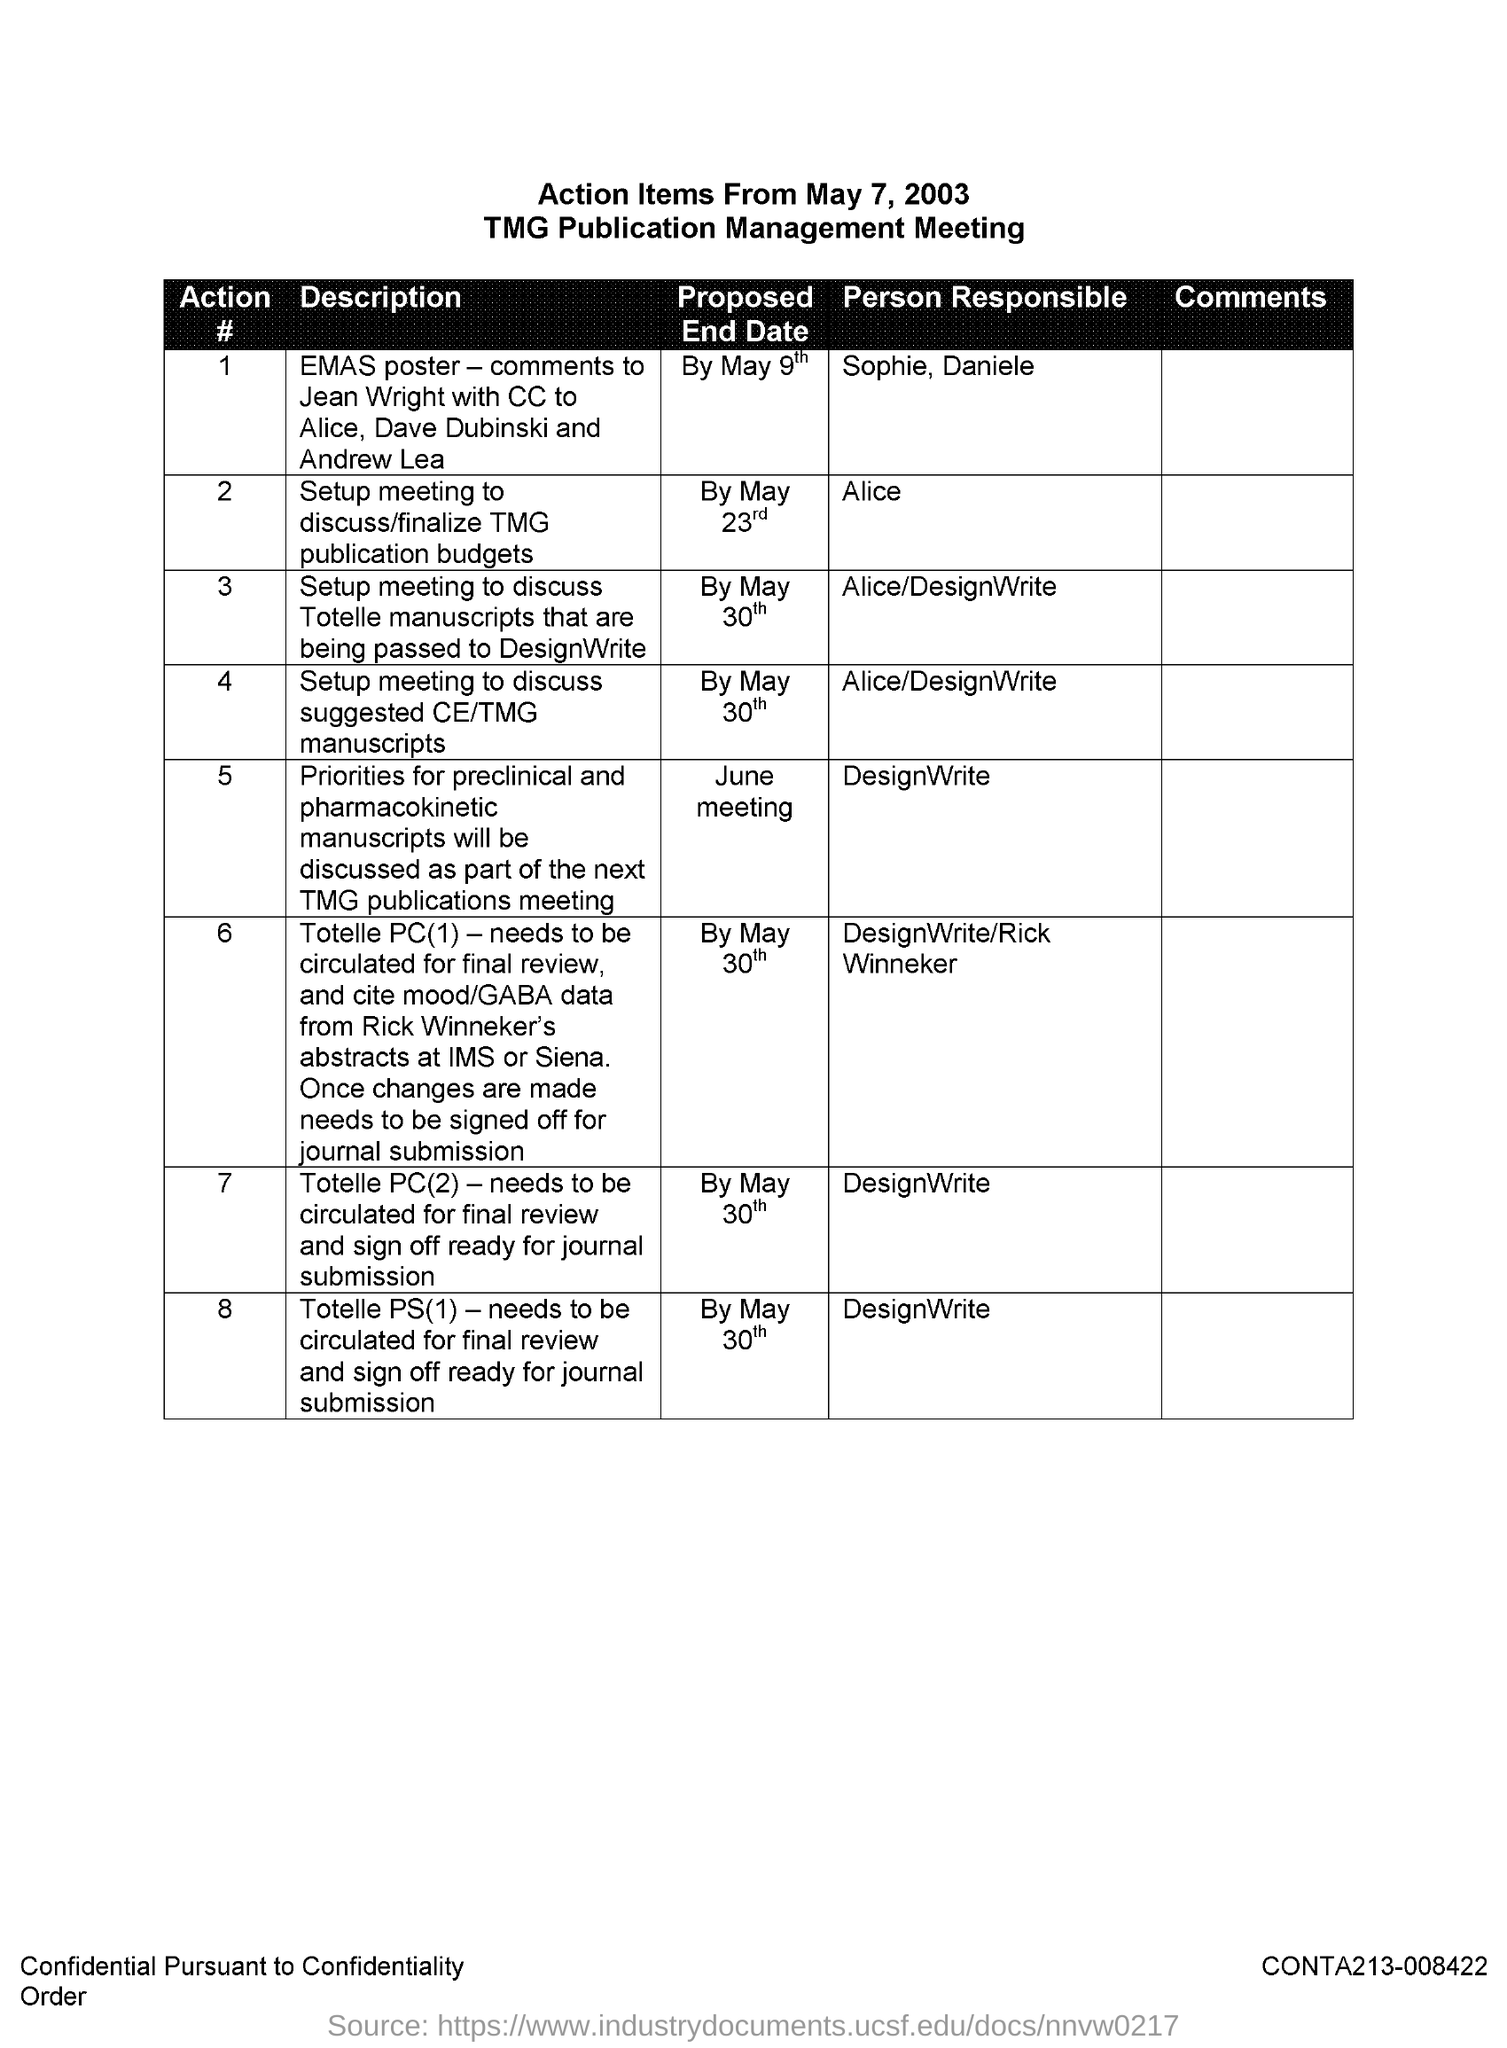Identify some key points in this picture. DesignWrite is responsible for action #8. The proposed end date for Action #4 is May 30th. The second title in the document is "TMG Publication Management Meeting.. The document is titled "Action Items From May 7, 2003. It is Alice who is responsible for action #2. 